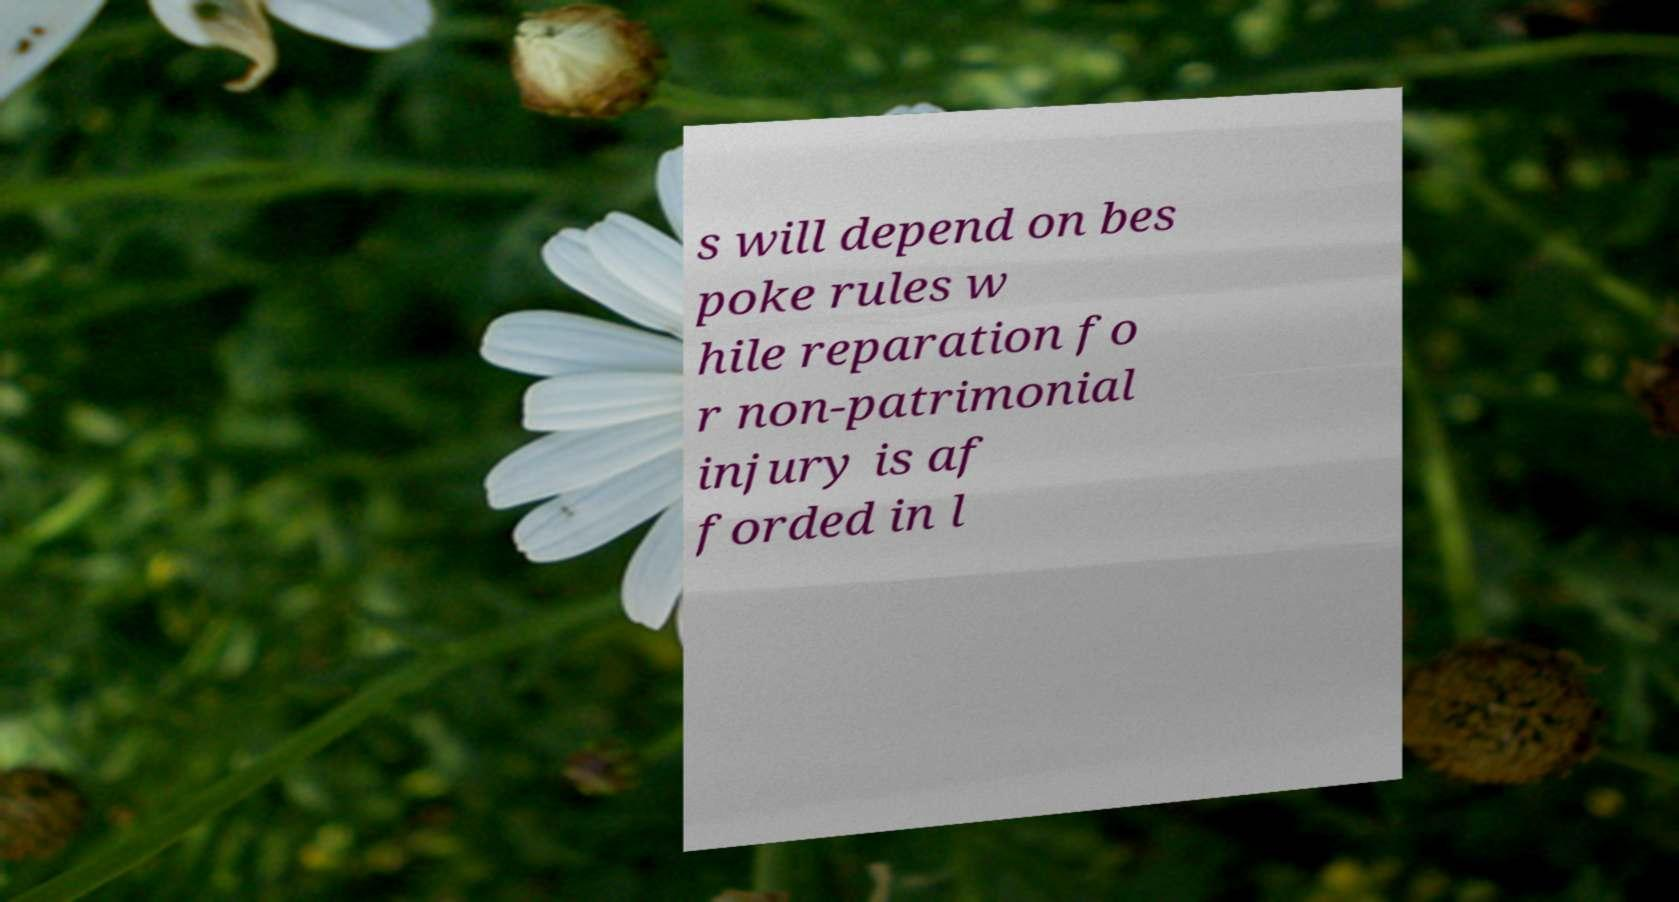Can you accurately transcribe the text from the provided image for me? s will depend on bes poke rules w hile reparation fo r non-patrimonial injury is af forded in l 